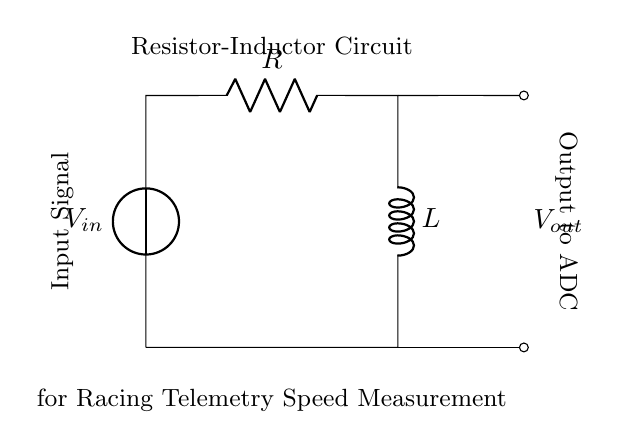What is the type of this circuit? The components shown are a resistor and an inductor wired in series, indicating that this circuit is a Resistor-Inductor (RL) circuit.
Answer: Resistor-Inductor What is the voltage source in this circuit? The circuit includes a voltage source labeled as V sub in at the left side, which provides input electrical energy to the circuit.
Answer: V in What are the two components shown in the circuit? The circuit diagram depicts a resistor and an inductor, identifiable by their respective symbols and labels.
Answer: Resistor and Inductor What is the output of the circuit? The output is taken from the two points marked at the right side of the circuit, labeled as V sub out, signifying the measured voltage ready for further processing.
Answer: V out What will happen to the output voltage when the input voltage increases? As the input voltage increases, the output voltage will also increase, since the relationship between input and output in an RL circuit is directly proportional under steady conditions.
Answer: Increase Why is an inductor used in this racing telemetry system? An inductor is used to filter or smooth the input signal to provide a more stable voltage output for accurate speed measurements, which is crucial for telemetry systems in racing applications.
Answer: To filter the signal What role does the resistor play in this circuit? The resistor limits the current flow and dissipates energy as heat, which can help protect the circuit components and stabilize the performance of the inductor in the telemetry system.
Answer: Current limiting 